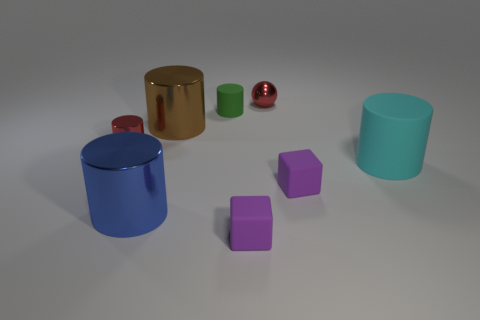There is a cylinder that is the same color as the small ball; what size is it?
Offer a terse response. Small. Is there a big metallic cylinder of the same color as the small sphere?
Your answer should be very brief. No. There is a shiny sphere that is the same size as the green cylinder; what color is it?
Offer a terse response. Red. Is there a purple rubber cube that is in front of the metal cylinder left of the large blue shiny cylinder?
Offer a very short reply. Yes. There is a green cylinder that is in front of the red ball; what is its material?
Your response must be concise. Rubber. Is the tiny cylinder that is behind the red cylinder made of the same material as the big cyan cylinder that is on the right side of the small red cylinder?
Your answer should be compact. Yes. Are there the same number of big shiny cylinders that are in front of the large blue shiny cylinder and cyan cylinders behind the tiny red metallic cylinder?
Your answer should be compact. Yes. What number of cyan spheres are the same material as the big blue cylinder?
Keep it short and to the point. 0. What shape is the shiny thing that is the same color as the ball?
Provide a succinct answer. Cylinder. What is the size of the green cylinder that is in front of the small red metallic thing that is behind the tiny red metallic cylinder?
Your answer should be very brief. Small. 